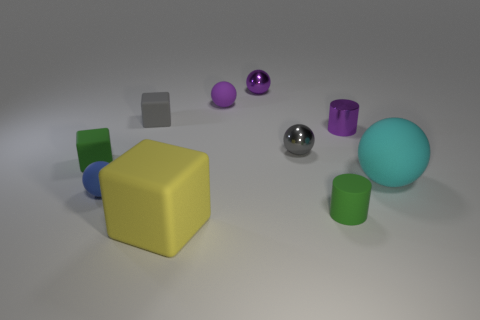Subtract all gray balls. How many balls are left? 4 Subtract all large balls. How many balls are left? 4 Subtract all blue spheres. Subtract all cyan blocks. How many spheres are left? 4 Subtract all cubes. How many objects are left? 7 Add 6 tiny blue things. How many tiny blue things exist? 7 Subtract 1 green cylinders. How many objects are left? 9 Subtract all rubber objects. Subtract all blue matte things. How many objects are left? 2 Add 4 green rubber cylinders. How many green rubber cylinders are left? 5 